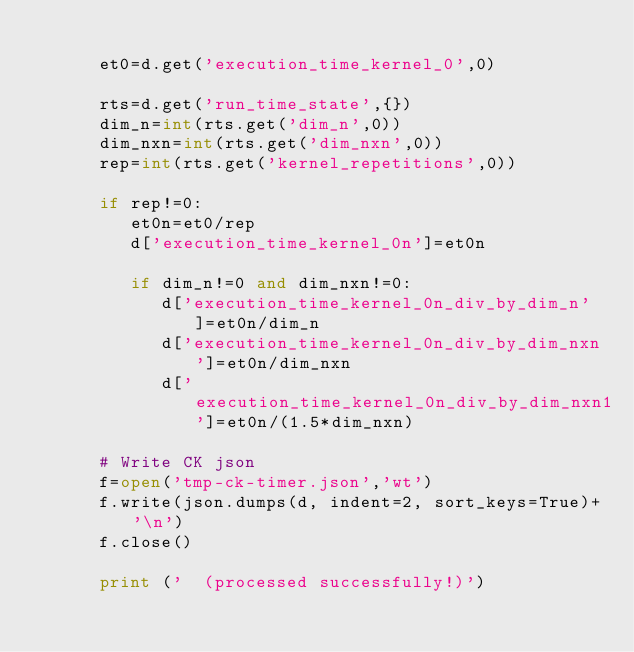Convert code to text. <code><loc_0><loc_0><loc_500><loc_500><_Python_>
      et0=d.get('execution_time_kernel_0',0)

      rts=d.get('run_time_state',{})
      dim_n=int(rts.get('dim_n',0))
      dim_nxn=int(rts.get('dim_nxn',0))
      rep=int(rts.get('kernel_repetitions',0))

      if rep!=0:
         et0n=et0/rep
         d['execution_time_kernel_0n']=et0n

         if dim_n!=0 and dim_nxn!=0:
            d['execution_time_kernel_0n_div_by_dim_n']=et0n/dim_n
            d['execution_time_kernel_0n_div_by_dim_nxn']=et0n/dim_nxn
            d['execution_time_kernel_0n_div_by_dim_nxn1']=et0n/(1.5*dim_nxn)

      # Write CK json
      f=open('tmp-ck-timer.json','wt')
      f.write(json.dumps(d, indent=2, sort_keys=True)+'\n')
      f.close()

      print ('  (processed successfully!)')
</code> 